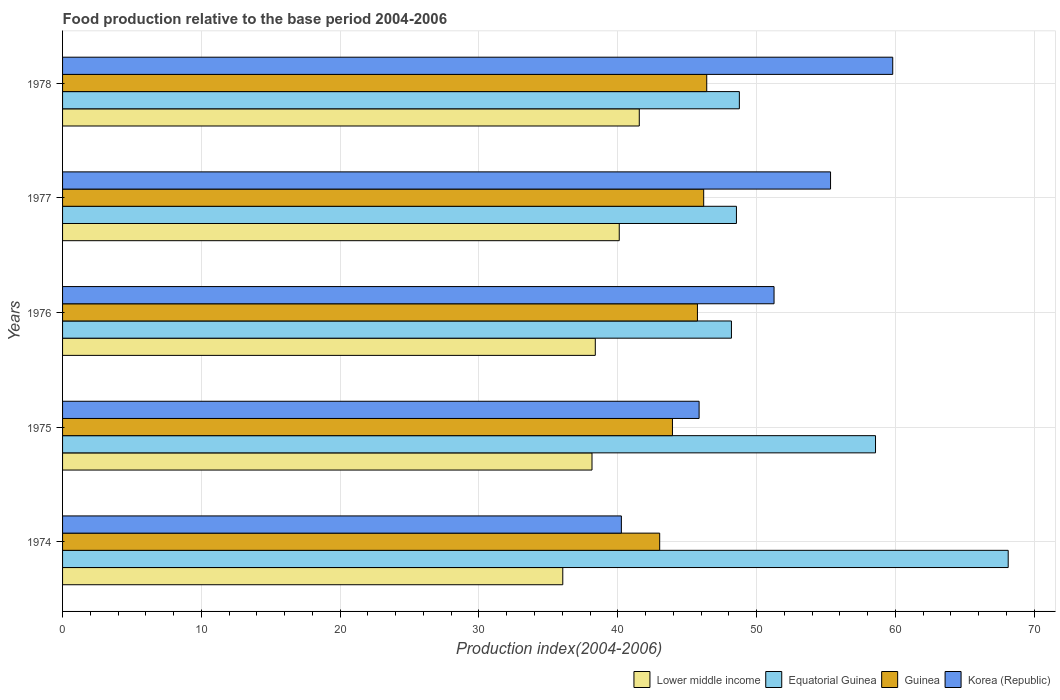How many different coloured bars are there?
Your response must be concise. 4. How many groups of bars are there?
Offer a very short reply. 5. Are the number of bars on each tick of the Y-axis equal?
Offer a terse response. Yes. How many bars are there on the 5th tick from the top?
Provide a short and direct response. 4. How many bars are there on the 1st tick from the bottom?
Make the answer very short. 4. What is the label of the 4th group of bars from the top?
Provide a succinct answer. 1975. What is the food production index in Lower middle income in 1974?
Provide a short and direct response. 36.04. Across all years, what is the maximum food production index in Lower middle income?
Your answer should be very brief. 41.55. Across all years, what is the minimum food production index in Korea (Republic)?
Offer a very short reply. 40.26. In which year was the food production index in Equatorial Guinea maximum?
Your response must be concise. 1974. In which year was the food production index in Lower middle income minimum?
Give a very brief answer. 1974. What is the total food production index in Equatorial Guinea in the graph?
Make the answer very short. 272.2. What is the difference between the food production index in Korea (Republic) in 1975 and that in 1976?
Offer a terse response. -5.4. What is the difference between the food production index in Lower middle income in 1975 and the food production index in Guinea in 1974?
Your answer should be compact. -4.88. What is the average food production index in Lower middle income per year?
Make the answer very short. 38.84. In the year 1975, what is the difference between the food production index in Guinea and food production index in Equatorial Guinea?
Ensure brevity in your answer.  -14.63. What is the ratio of the food production index in Equatorial Guinea in 1974 to that in 1975?
Your answer should be very brief. 1.16. What is the difference between the highest and the second highest food production index in Lower middle income?
Your answer should be very brief. 1.44. What is the difference between the highest and the lowest food production index in Korea (Republic)?
Keep it short and to the point. 19.55. In how many years, is the food production index in Korea (Republic) greater than the average food production index in Korea (Republic) taken over all years?
Ensure brevity in your answer.  3. Is the sum of the food production index in Lower middle income in 1974 and 1977 greater than the maximum food production index in Equatorial Guinea across all years?
Keep it short and to the point. Yes. What does the 1st bar from the top in 1975 represents?
Keep it short and to the point. Korea (Republic). What does the 3rd bar from the bottom in 1975 represents?
Make the answer very short. Guinea. Is it the case that in every year, the sum of the food production index in Korea (Republic) and food production index in Equatorial Guinea is greater than the food production index in Lower middle income?
Ensure brevity in your answer.  Yes. How many bars are there?
Provide a succinct answer. 20. How many years are there in the graph?
Provide a short and direct response. 5. What is the difference between two consecutive major ticks on the X-axis?
Provide a succinct answer. 10. Does the graph contain any zero values?
Make the answer very short. No. Where does the legend appear in the graph?
Your answer should be compact. Bottom right. How many legend labels are there?
Make the answer very short. 4. How are the legend labels stacked?
Keep it short and to the point. Horizontal. What is the title of the graph?
Give a very brief answer. Food production relative to the base period 2004-2006. What is the label or title of the X-axis?
Provide a short and direct response. Production index(2004-2006). What is the Production index(2004-2006) of Lower middle income in 1974?
Offer a terse response. 36.04. What is the Production index(2004-2006) in Equatorial Guinea in 1974?
Provide a succinct answer. 68.13. What is the Production index(2004-2006) in Guinea in 1974?
Your response must be concise. 43.02. What is the Production index(2004-2006) in Korea (Republic) in 1974?
Your response must be concise. 40.26. What is the Production index(2004-2006) in Lower middle income in 1975?
Provide a succinct answer. 38.14. What is the Production index(2004-2006) in Equatorial Guinea in 1975?
Keep it short and to the point. 58.57. What is the Production index(2004-2006) of Guinea in 1975?
Give a very brief answer. 43.94. What is the Production index(2004-2006) of Korea (Republic) in 1975?
Give a very brief answer. 45.86. What is the Production index(2004-2006) of Lower middle income in 1976?
Your answer should be compact. 38.38. What is the Production index(2004-2006) of Equatorial Guinea in 1976?
Your answer should be very brief. 48.19. What is the Production index(2004-2006) of Guinea in 1976?
Provide a short and direct response. 45.74. What is the Production index(2004-2006) of Korea (Republic) in 1976?
Your answer should be compact. 51.26. What is the Production index(2004-2006) in Lower middle income in 1977?
Keep it short and to the point. 40.11. What is the Production index(2004-2006) in Equatorial Guinea in 1977?
Your answer should be compact. 48.55. What is the Production index(2004-2006) in Guinea in 1977?
Your answer should be compact. 46.19. What is the Production index(2004-2006) in Korea (Republic) in 1977?
Your answer should be very brief. 55.33. What is the Production index(2004-2006) of Lower middle income in 1978?
Ensure brevity in your answer.  41.55. What is the Production index(2004-2006) in Equatorial Guinea in 1978?
Your response must be concise. 48.76. What is the Production index(2004-2006) in Guinea in 1978?
Ensure brevity in your answer.  46.41. What is the Production index(2004-2006) in Korea (Republic) in 1978?
Offer a very short reply. 59.81. Across all years, what is the maximum Production index(2004-2006) of Lower middle income?
Your answer should be very brief. 41.55. Across all years, what is the maximum Production index(2004-2006) of Equatorial Guinea?
Keep it short and to the point. 68.13. Across all years, what is the maximum Production index(2004-2006) in Guinea?
Offer a very short reply. 46.41. Across all years, what is the maximum Production index(2004-2006) of Korea (Republic)?
Your response must be concise. 59.81. Across all years, what is the minimum Production index(2004-2006) of Lower middle income?
Keep it short and to the point. 36.04. Across all years, what is the minimum Production index(2004-2006) of Equatorial Guinea?
Ensure brevity in your answer.  48.19. Across all years, what is the minimum Production index(2004-2006) of Guinea?
Your response must be concise. 43.02. Across all years, what is the minimum Production index(2004-2006) in Korea (Republic)?
Offer a very short reply. 40.26. What is the total Production index(2004-2006) in Lower middle income in the graph?
Keep it short and to the point. 194.22. What is the total Production index(2004-2006) in Equatorial Guinea in the graph?
Provide a short and direct response. 272.2. What is the total Production index(2004-2006) of Guinea in the graph?
Your response must be concise. 225.3. What is the total Production index(2004-2006) of Korea (Republic) in the graph?
Offer a terse response. 252.52. What is the difference between the Production index(2004-2006) in Lower middle income in 1974 and that in 1975?
Your answer should be compact. -2.1. What is the difference between the Production index(2004-2006) of Equatorial Guinea in 1974 and that in 1975?
Give a very brief answer. 9.56. What is the difference between the Production index(2004-2006) in Guinea in 1974 and that in 1975?
Your response must be concise. -0.92. What is the difference between the Production index(2004-2006) in Korea (Republic) in 1974 and that in 1975?
Your answer should be compact. -5.6. What is the difference between the Production index(2004-2006) in Lower middle income in 1974 and that in 1976?
Provide a succinct answer. -2.34. What is the difference between the Production index(2004-2006) in Equatorial Guinea in 1974 and that in 1976?
Keep it short and to the point. 19.94. What is the difference between the Production index(2004-2006) of Guinea in 1974 and that in 1976?
Offer a terse response. -2.72. What is the difference between the Production index(2004-2006) of Lower middle income in 1974 and that in 1977?
Your answer should be compact. -4.07. What is the difference between the Production index(2004-2006) in Equatorial Guinea in 1974 and that in 1977?
Make the answer very short. 19.58. What is the difference between the Production index(2004-2006) in Guinea in 1974 and that in 1977?
Provide a short and direct response. -3.17. What is the difference between the Production index(2004-2006) of Korea (Republic) in 1974 and that in 1977?
Provide a succinct answer. -15.07. What is the difference between the Production index(2004-2006) of Lower middle income in 1974 and that in 1978?
Keep it short and to the point. -5.51. What is the difference between the Production index(2004-2006) in Equatorial Guinea in 1974 and that in 1978?
Your answer should be very brief. 19.37. What is the difference between the Production index(2004-2006) in Guinea in 1974 and that in 1978?
Offer a terse response. -3.39. What is the difference between the Production index(2004-2006) in Korea (Republic) in 1974 and that in 1978?
Your answer should be very brief. -19.55. What is the difference between the Production index(2004-2006) of Lower middle income in 1975 and that in 1976?
Provide a succinct answer. -0.24. What is the difference between the Production index(2004-2006) in Equatorial Guinea in 1975 and that in 1976?
Ensure brevity in your answer.  10.38. What is the difference between the Production index(2004-2006) in Korea (Republic) in 1975 and that in 1976?
Your answer should be compact. -5.4. What is the difference between the Production index(2004-2006) of Lower middle income in 1975 and that in 1977?
Offer a terse response. -1.96. What is the difference between the Production index(2004-2006) of Equatorial Guinea in 1975 and that in 1977?
Ensure brevity in your answer.  10.02. What is the difference between the Production index(2004-2006) in Guinea in 1975 and that in 1977?
Offer a terse response. -2.25. What is the difference between the Production index(2004-2006) in Korea (Republic) in 1975 and that in 1977?
Offer a very short reply. -9.47. What is the difference between the Production index(2004-2006) of Lower middle income in 1975 and that in 1978?
Provide a short and direct response. -3.41. What is the difference between the Production index(2004-2006) of Equatorial Guinea in 1975 and that in 1978?
Your answer should be very brief. 9.81. What is the difference between the Production index(2004-2006) in Guinea in 1975 and that in 1978?
Your response must be concise. -2.47. What is the difference between the Production index(2004-2006) in Korea (Republic) in 1975 and that in 1978?
Provide a short and direct response. -13.95. What is the difference between the Production index(2004-2006) in Lower middle income in 1976 and that in 1977?
Offer a terse response. -1.73. What is the difference between the Production index(2004-2006) of Equatorial Guinea in 1976 and that in 1977?
Make the answer very short. -0.36. What is the difference between the Production index(2004-2006) of Guinea in 1976 and that in 1977?
Your answer should be very brief. -0.45. What is the difference between the Production index(2004-2006) of Korea (Republic) in 1976 and that in 1977?
Make the answer very short. -4.07. What is the difference between the Production index(2004-2006) in Lower middle income in 1976 and that in 1978?
Ensure brevity in your answer.  -3.17. What is the difference between the Production index(2004-2006) of Equatorial Guinea in 1976 and that in 1978?
Give a very brief answer. -0.57. What is the difference between the Production index(2004-2006) in Guinea in 1976 and that in 1978?
Offer a terse response. -0.67. What is the difference between the Production index(2004-2006) of Korea (Republic) in 1976 and that in 1978?
Your answer should be very brief. -8.55. What is the difference between the Production index(2004-2006) of Lower middle income in 1977 and that in 1978?
Provide a succinct answer. -1.44. What is the difference between the Production index(2004-2006) in Equatorial Guinea in 1977 and that in 1978?
Your answer should be compact. -0.21. What is the difference between the Production index(2004-2006) of Guinea in 1977 and that in 1978?
Give a very brief answer. -0.22. What is the difference between the Production index(2004-2006) in Korea (Republic) in 1977 and that in 1978?
Make the answer very short. -4.48. What is the difference between the Production index(2004-2006) in Lower middle income in 1974 and the Production index(2004-2006) in Equatorial Guinea in 1975?
Offer a very short reply. -22.53. What is the difference between the Production index(2004-2006) of Lower middle income in 1974 and the Production index(2004-2006) of Guinea in 1975?
Make the answer very short. -7.9. What is the difference between the Production index(2004-2006) in Lower middle income in 1974 and the Production index(2004-2006) in Korea (Republic) in 1975?
Your answer should be compact. -9.82. What is the difference between the Production index(2004-2006) in Equatorial Guinea in 1974 and the Production index(2004-2006) in Guinea in 1975?
Provide a short and direct response. 24.19. What is the difference between the Production index(2004-2006) in Equatorial Guinea in 1974 and the Production index(2004-2006) in Korea (Republic) in 1975?
Provide a succinct answer. 22.27. What is the difference between the Production index(2004-2006) of Guinea in 1974 and the Production index(2004-2006) of Korea (Republic) in 1975?
Give a very brief answer. -2.84. What is the difference between the Production index(2004-2006) of Lower middle income in 1974 and the Production index(2004-2006) of Equatorial Guinea in 1976?
Give a very brief answer. -12.15. What is the difference between the Production index(2004-2006) in Lower middle income in 1974 and the Production index(2004-2006) in Guinea in 1976?
Offer a very short reply. -9.7. What is the difference between the Production index(2004-2006) in Lower middle income in 1974 and the Production index(2004-2006) in Korea (Republic) in 1976?
Ensure brevity in your answer.  -15.22. What is the difference between the Production index(2004-2006) of Equatorial Guinea in 1974 and the Production index(2004-2006) of Guinea in 1976?
Give a very brief answer. 22.39. What is the difference between the Production index(2004-2006) in Equatorial Guinea in 1974 and the Production index(2004-2006) in Korea (Republic) in 1976?
Offer a terse response. 16.87. What is the difference between the Production index(2004-2006) in Guinea in 1974 and the Production index(2004-2006) in Korea (Republic) in 1976?
Your answer should be very brief. -8.24. What is the difference between the Production index(2004-2006) of Lower middle income in 1974 and the Production index(2004-2006) of Equatorial Guinea in 1977?
Provide a succinct answer. -12.51. What is the difference between the Production index(2004-2006) in Lower middle income in 1974 and the Production index(2004-2006) in Guinea in 1977?
Your answer should be very brief. -10.15. What is the difference between the Production index(2004-2006) of Lower middle income in 1974 and the Production index(2004-2006) of Korea (Republic) in 1977?
Provide a short and direct response. -19.29. What is the difference between the Production index(2004-2006) of Equatorial Guinea in 1974 and the Production index(2004-2006) of Guinea in 1977?
Offer a very short reply. 21.94. What is the difference between the Production index(2004-2006) in Guinea in 1974 and the Production index(2004-2006) in Korea (Republic) in 1977?
Offer a very short reply. -12.31. What is the difference between the Production index(2004-2006) in Lower middle income in 1974 and the Production index(2004-2006) in Equatorial Guinea in 1978?
Your response must be concise. -12.72. What is the difference between the Production index(2004-2006) in Lower middle income in 1974 and the Production index(2004-2006) in Guinea in 1978?
Provide a succinct answer. -10.37. What is the difference between the Production index(2004-2006) of Lower middle income in 1974 and the Production index(2004-2006) of Korea (Republic) in 1978?
Provide a short and direct response. -23.77. What is the difference between the Production index(2004-2006) of Equatorial Guinea in 1974 and the Production index(2004-2006) of Guinea in 1978?
Provide a succinct answer. 21.72. What is the difference between the Production index(2004-2006) in Equatorial Guinea in 1974 and the Production index(2004-2006) in Korea (Republic) in 1978?
Provide a short and direct response. 8.32. What is the difference between the Production index(2004-2006) in Guinea in 1974 and the Production index(2004-2006) in Korea (Republic) in 1978?
Provide a short and direct response. -16.79. What is the difference between the Production index(2004-2006) in Lower middle income in 1975 and the Production index(2004-2006) in Equatorial Guinea in 1976?
Your answer should be very brief. -10.05. What is the difference between the Production index(2004-2006) in Lower middle income in 1975 and the Production index(2004-2006) in Guinea in 1976?
Offer a very short reply. -7.6. What is the difference between the Production index(2004-2006) in Lower middle income in 1975 and the Production index(2004-2006) in Korea (Republic) in 1976?
Provide a short and direct response. -13.12. What is the difference between the Production index(2004-2006) in Equatorial Guinea in 1975 and the Production index(2004-2006) in Guinea in 1976?
Your answer should be compact. 12.83. What is the difference between the Production index(2004-2006) in Equatorial Guinea in 1975 and the Production index(2004-2006) in Korea (Republic) in 1976?
Provide a succinct answer. 7.31. What is the difference between the Production index(2004-2006) in Guinea in 1975 and the Production index(2004-2006) in Korea (Republic) in 1976?
Make the answer very short. -7.32. What is the difference between the Production index(2004-2006) in Lower middle income in 1975 and the Production index(2004-2006) in Equatorial Guinea in 1977?
Provide a short and direct response. -10.41. What is the difference between the Production index(2004-2006) of Lower middle income in 1975 and the Production index(2004-2006) of Guinea in 1977?
Your answer should be compact. -8.05. What is the difference between the Production index(2004-2006) in Lower middle income in 1975 and the Production index(2004-2006) in Korea (Republic) in 1977?
Keep it short and to the point. -17.19. What is the difference between the Production index(2004-2006) in Equatorial Guinea in 1975 and the Production index(2004-2006) in Guinea in 1977?
Your answer should be very brief. 12.38. What is the difference between the Production index(2004-2006) in Equatorial Guinea in 1975 and the Production index(2004-2006) in Korea (Republic) in 1977?
Give a very brief answer. 3.24. What is the difference between the Production index(2004-2006) in Guinea in 1975 and the Production index(2004-2006) in Korea (Republic) in 1977?
Your response must be concise. -11.39. What is the difference between the Production index(2004-2006) of Lower middle income in 1975 and the Production index(2004-2006) of Equatorial Guinea in 1978?
Your answer should be compact. -10.62. What is the difference between the Production index(2004-2006) in Lower middle income in 1975 and the Production index(2004-2006) in Guinea in 1978?
Your answer should be very brief. -8.27. What is the difference between the Production index(2004-2006) in Lower middle income in 1975 and the Production index(2004-2006) in Korea (Republic) in 1978?
Your answer should be very brief. -21.67. What is the difference between the Production index(2004-2006) of Equatorial Guinea in 1975 and the Production index(2004-2006) of Guinea in 1978?
Keep it short and to the point. 12.16. What is the difference between the Production index(2004-2006) in Equatorial Guinea in 1975 and the Production index(2004-2006) in Korea (Republic) in 1978?
Offer a very short reply. -1.24. What is the difference between the Production index(2004-2006) in Guinea in 1975 and the Production index(2004-2006) in Korea (Republic) in 1978?
Your answer should be very brief. -15.87. What is the difference between the Production index(2004-2006) of Lower middle income in 1976 and the Production index(2004-2006) of Equatorial Guinea in 1977?
Offer a very short reply. -10.17. What is the difference between the Production index(2004-2006) in Lower middle income in 1976 and the Production index(2004-2006) in Guinea in 1977?
Your answer should be compact. -7.81. What is the difference between the Production index(2004-2006) in Lower middle income in 1976 and the Production index(2004-2006) in Korea (Republic) in 1977?
Make the answer very short. -16.95. What is the difference between the Production index(2004-2006) of Equatorial Guinea in 1976 and the Production index(2004-2006) of Guinea in 1977?
Your response must be concise. 2. What is the difference between the Production index(2004-2006) of Equatorial Guinea in 1976 and the Production index(2004-2006) of Korea (Republic) in 1977?
Provide a short and direct response. -7.14. What is the difference between the Production index(2004-2006) of Guinea in 1976 and the Production index(2004-2006) of Korea (Republic) in 1977?
Offer a very short reply. -9.59. What is the difference between the Production index(2004-2006) of Lower middle income in 1976 and the Production index(2004-2006) of Equatorial Guinea in 1978?
Ensure brevity in your answer.  -10.38. What is the difference between the Production index(2004-2006) of Lower middle income in 1976 and the Production index(2004-2006) of Guinea in 1978?
Give a very brief answer. -8.03. What is the difference between the Production index(2004-2006) of Lower middle income in 1976 and the Production index(2004-2006) of Korea (Republic) in 1978?
Offer a terse response. -21.43. What is the difference between the Production index(2004-2006) of Equatorial Guinea in 1976 and the Production index(2004-2006) of Guinea in 1978?
Your response must be concise. 1.78. What is the difference between the Production index(2004-2006) of Equatorial Guinea in 1976 and the Production index(2004-2006) of Korea (Republic) in 1978?
Keep it short and to the point. -11.62. What is the difference between the Production index(2004-2006) in Guinea in 1976 and the Production index(2004-2006) in Korea (Republic) in 1978?
Keep it short and to the point. -14.07. What is the difference between the Production index(2004-2006) in Lower middle income in 1977 and the Production index(2004-2006) in Equatorial Guinea in 1978?
Give a very brief answer. -8.65. What is the difference between the Production index(2004-2006) in Lower middle income in 1977 and the Production index(2004-2006) in Guinea in 1978?
Provide a succinct answer. -6.3. What is the difference between the Production index(2004-2006) in Lower middle income in 1977 and the Production index(2004-2006) in Korea (Republic) in 1978?
Provide a short and direct response. -19.7. What is the difference between the Production index(2004-2006) of Equatorial Guinea in 1977 and the Production index(2004-2006) of Guinea in 1978?
Offer a terse response. 2.14. What is the difference between the Production index(2004-2006) in Equatorial Guinea in 1977 and the Production index(2004-2006) in Korea (Republic) in 1978?
Give a very brief answer. -11.26. What is the difference between the Production index(2004-2006) in Guinea in 1977 and the Production index(2004-2006) in Korea (Republic) in 1978?
Keep it short and to the point. -13.62. What is the average Production index(2004-2006) of Lower middle income per year?
Offer a terse response. 38.84. What is the average Production index(2004-2006) in Equatorial Guinea per year?
Ensure brevity in your answer.  54.44. What is the average Production index(2004-2006) in Guinea per year?
Your response must be concise. 45.06. What is the average Production index(2004-2006) in Korea (Republic) per year?
Offer a terse response. 50.5. In the year 1974, what is the difference between the Production index(2004-2006) of Lower middle income and Production index(2004-2006) of Equatorial Guinea?
Provide a succinct answer. -32.09. In the year 1974, what is the difference between the Production index(2004-2006) of Lower middle income and Production index(2004-2006) of Guinea?
Give a very brief answer. -6.98. In the year 1974, what is the difference between the Production index(2004-2006) in Lower middle income and Production index(2004-2006) in Korea (Republic)?
Your response must be concise. -4.22. In the year 1974, what is the difference between the Production index(2004-2006) in Equatorial Guinea and Production index(2004-2006) in Guinea?
Keep it short and to the point. 25.11. In the year 1974, what is the difference between the Production index(2004-2006) of Equatorial Guinea and Production index(2004-2006) of Korea (Republic)?
Give a very brief answer. 27.87. In the year 1974, what is the difference between the Production index(2004-2006) in Guinea and Production index(2004-2006) in Korea (Republic)?
Give a very brief answer. 2.76. In the year 1975, what is the difference between the Production index(2004-2006) of Lower middle income and Production index(2004-2006) of Equatorial Guinea?
Your answer should be compact. -20.43. In the year 1975, what is the difference between the Production index(2004-2006) in Lower middle income and Production index(2004-2006) in Guinea?
Your response must be concise. -5.8. In the year 1975, what is the difference between the Production index(2004-2006) of Lower middle income and Production index(2004-2006) of Korea (Republic)?
Your answer should be compact. -7.72. In the year 1975, what is the difference between the Production index(2004-2006) of Equatorial Guinea and Production index(2004-2006) of Guinea?
Provide a short and direct response. 14.63. In the year 1975, what is the difference between the Production index(2004-2006) of Equatorial Guinea and Production index(2004-2006) of Korea (Republic)?
Provide a short and direct response. 12.71. In the year 1975, what is the difference between the Production index(2004-2006) in Guinea and Production index(2004-2006) in Korea (Republic)?
Offer a terse response. -1.92. In the year 1976, what is the difference between the Production index(2004-2006) of Lower middle income and Production index(2004-2006) of Equatorial Guinea?
Your answer should be very brief. -9.81. In the year 1976, what is the difference between the Production index(2004-2006) in Lower middle income and Production index(2004-2006) in Guinea?
Your answer should be compact. -7.36. In the year 1976, what is the difference between the Production index(2004-2006) of Lower middle income and Production index(2004-2006) of Korea (Republic)?
Your answer should be very brief. -12.88. In the year 1976, what is the difference between the Production index(2004-2006) in Equatorial Guinea and Production index(2004-2006) in Guinea?
Your answer should be compact. 2.45. In the year 1976, what is the difference between the Production index(2004-2006) in Equatorial Guinea and Production index(2004-2006) in Korea (Republic)?
Make the answer very short. -3.07. In the year 1976, what is the difference between the Production index(2004-2006) of Guinea and Production index(2004-2006) of Korea (Republic)?
Your answer should be compact. -5.52. In the year 1977, what is the difference between the Production index(2004-2006) in Lower middle income and Production index(2004-2006) in Equatorial Guinea?
Provide a short and direct response. -8.44. In the year 1977, what is the difference between the Production index(2004-2006) in Lower middle income and Production index(2004-2006) in Guinea?
Provide a short and direct response. -6.08. In the year 1977, what is the difference between the Production index(2004-2006) of Lower middle income and Production index(2004-2006) of Korea (Republic)?
Your answer should be compact. -15.22. In the year 1977, what is the difference between the Production index(2004-2006) of Equatorial Guinea and Production index(2004-2006) of Guinea?
Ensure brevity in your answer.  2.36. In the year 1977, what is the difference between the Production index(2004-2006) in Equatorial Guinea and Production index(2004-2006) in Korea (Republic)?
Your answer should be very brief. -6.78. In the year 1977, what is the difference between the Production index(2004-2006) in Guinea and Production index(2004-2006) in Korea (Republic)?
Offer a very short reply. -9.14. In the year 1978, what is the difference between the Production index(2004-2006) in Lower middle income and Production index(2004-2006) in Equatorial Guinea?
Make the answer very short. -7.21. In the year 1978, what is the difference between the Production index(2004-2006) in Lower middle income and Production index(2004-2006) in Guinea?
Offer a terse response. -4.86. In the year 1978, what is the difference between the Production index(2004-2006) of Lower middle income and Production index(2004-2006) of Korea (Republic)?
Ensure brevity in your answer.  -18.26. In the year 1978, what is the difference between the Production index(2004-2006) in Equatorial Guinea and Production index(2004-2006) in Guinea?
Offer a terse response. 2.35. In the year 1978, what is the difference between the Production index(2004-2006) of Equatorial Guinea and Production index(2004-2006) of Korea (Republic)?
Your answer should be very brief. -11.05. In the year 1978, what is the difference between the Production index(2004-2006) of Guinea and Production index(2004-2006) of Korea (Republic)?
Offer a very short reply. -13.4. What is the ratio of the Production index(2004-2006) of Lower middle income in 1974 to that in 1975?
Provide a succinct answer. 0.94. What is the ratio of the Production index(2004-2006) of Equatorial Guinea in 1974 to that in 1975?
Your answer should be compact. 1.16. What is the ratio of the Production index(2004-2006) in Guinea in 1974 to that in 1975?
Offer a very short reply. 0.98. What is the ratio of the Production index(2004-2006) in Korea (Republic) in 1974 to that in 1975?
Provide a succinct answer. 0.88. What is the ratio of the Production index(2004-2006) of Lower middle income in 1974 to that in 1976?
Your answer should be compact. 0.94. What is the ratio of the Production index(2004-2006) of Equatorial Guinea in 1974 to that in 1976?
Your answer should be very brief. 1.41. What is the ratio of the Production index(2004-2006) in Guinea in 1974 to that in 1976?
Your response must be concise. 0.94. What is the ratio of the Production index(2004-2006) of Korea (Republic) in 1974 to that in 1976?
Your response must be concise. 0.79. What is the ratio of the Production index(2004-2006) of Lower middle income in 1974 to that in 1977?
Provide a short and direct response. 0.9. What is the ratio of the Production index(2004-2006) of Equatorial Guinea in 1974 to that in 1977?
Offer a very short reply. 1.4. What is the ratio of the Production index(2004-2006) in Guinea in 1974 to that in 1977?
Keep it short and to the point. 0.93. What is the ratio of the Production index(2004-2006) in Korea (Republic) in 1974 to that in 1977?
Keep it short and to the point. 0.73. What is the ratio of the Production index(2004-2006) of Lower middle income in 1974 to that in 1978?
Give a very brief answer. 0.87. What is the ratio of the Production index(2004-2006) in Equatorial Guinea in 1974 to that in 1978?
Make the answer very short. 1.4. What is the ratio of the Production index(2004-2006) of Guinea in 1974 to that in 1978?
Make the answer very short. 0.93. What is the ratio of the Production index(2004-2006) of Korea (Republic) in 1974 to that in 1978?
Offer a terse response. 0.67. What is the ratio of the Production index(2004-2006) in Lower middle income in 1975 to that in 1976?
Give a very brief answer. 0.99. What is the ratio of the Production index(2004-2006) of Equatorial Guinea in 1975 to that in 1976?
Offer a terse response. 1.22. What is the ratio of the Production index(2004-2006) in Guinea in 1975 to that in 1976?
Give a very brief answer. 0.96. What is the ratio of the Production index(2004-2006) of Korea (Republic) in 1975 to that in 1976?
Make the answer very short. 0.89. What is the ratio of the Production index(2004-2006) of Lower middle income in 1975 to that in 1977?
Your response must be concise. 0.95. What is the ratio of the Production index(2004-2006) of Equatorial Guinea in 1975 to that in 1977?
Keep it short and to the point. 1.21. What is the ratio of the Production index(2004-2006) of Guinea in 1975 to that in 1977?
Offer a very short reply. 0.95. What is the ratio of the Production index(2004-2006) in Korea (Republic) in 1975 to that in 1977?
Ensure brevity in your answer.  0.83. What is the ratio of the Production index(2004-2006) in Lower middle income in 1975 to that in 1978?
Keep it short and to the point. 0.92. What is the ratio of the Production index(2004-2006) in Equatorial Guinea in 1975 to that in 1978?
Ensure brevity in your answer.  1.2. What is the ratio of the Production index(2004-2006) of Guinea in 1975 to that in 1978?
Provide a succinct answer. 0.95. What is the ratio of the Production index(2004-2006) of Korea (Republic) in 1975 to that in 1978?
Ensure brevity in your answer.  0.77. What is the ratio of the Production index(2004-2006) of Lower middle income in 1976 to that in 1977?
Ensure brevity in your answer.  0.96. What is the ratio of the Production index(2004-2006) in Guinea in 1976 to that in 1977?
Give a very brief answer. 0.99. What is the ratio of the Production index(2004-2006) in Korea (Republic) in 1976 to that in 1977?
Offer a terse response. 0.93. What is the ratio of the Production index(2004-2006) of Lower middle income in 1976 to that in 1978?
Make the answer very short. 0.92. What is the ratio of the Production index(2004-2006) of Equatorial Guinea in 1976 to that in 1978?
Provide a succinct answer. 0.99. What is the ratio of the Production index(2004-2006) in Guinea in 1976 to that in 1978?
Your answer should be very brief. 0.99. What is the ratio of the Production index(2004-2006) in Korea (Republic) in 1976 to that in 1978?
Keep it short and to the point. 0.86. What is the ratio of the Production index(2004-2006) in Lower middle income in 1977 to that in 1978?
Offer a very short reply. 0.97. What is the ratio of the Production index(2004-2006) in Equatorial Guinea in 1977 to that in 1978?
Your response must be concise. 1. What is the ratio of the Production index(2004-2006) of Korea (Republic) in 1977 to that in 1978?
Offer a terse response. 0.93. What is the difference between the highest and the second highest Production index(2004-2006) in Lower middle income?
Make the answer very short. 1.44. What is the difference between the highest and the second highest Production index(2004-2006) in Equatorial Guinea?
Your answer should be very brief. 9.56. What is the difference between the highest and the second highest Production index(2004-2006) in Guinea?
Offer a very short reply. 0.22. What is the difference between the highest and the second highest Production index(2004-2006) in Korea (Republic)?
Offer a terse response. 4.48. What is the difference between the highest and the lowest Production index(2004-2006) of Lower middle income?
Provide a succinct answer. 5.51. What is the difference between the highest and the lowest Production index(2004-2006) of Equatorial Guinea?
Your answer should be compact. 19.94. What is the difference between the highest and the lowest Production index(2004-2006) in Guinea?
Keep it short and to the point. 3.39. What is the difference between the highest and the lowest Production index(2004-2006) of Korea (Republic)?
Provide a short and direct response. 19.55. 